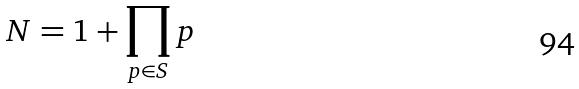<formula> <loc_0><loc_0><loc_500><loc_500>N = 1 + \prod _ { p \in S } p</formula> 